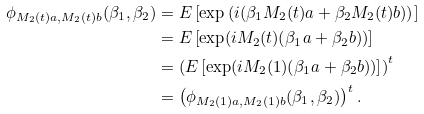<formula> <loc_0><loc_0><loc_500><loc_500>\phi _ { M _ { 2 } ( t ) a , M _ { 2 } ( t ) b } ( \beta _ { 1 } , \beta _ { 2 } ) & = E \left [ \exp \left ( i ( \beta _ { 1 } M _ { 2 } ( t ) a + \beta _ { 2 } M _ { 2 } ( t ) b ) \right ) \right ] \\ & = E \left [ \exp ( i M _ { 2 } ( t ) ( \beta _ { 1 } a + \beta _ { 2 } b ) ) \right ] \\ & = \left ( E \left [ \exp ( i M _ { 2 } ( 1 ) ( \beta _ { 1 } a + \beta _ { 2 } b ) ) \right ] \right ) ^ { t } \\ & = \left ( \phi _ { M _ { 2 } ( 1 ) a , M _ { 2 } ( 1 ) b } ( \beta _ { 1 } , \beta _ { 2 } ) \right ) ^ { t } .</formula> 